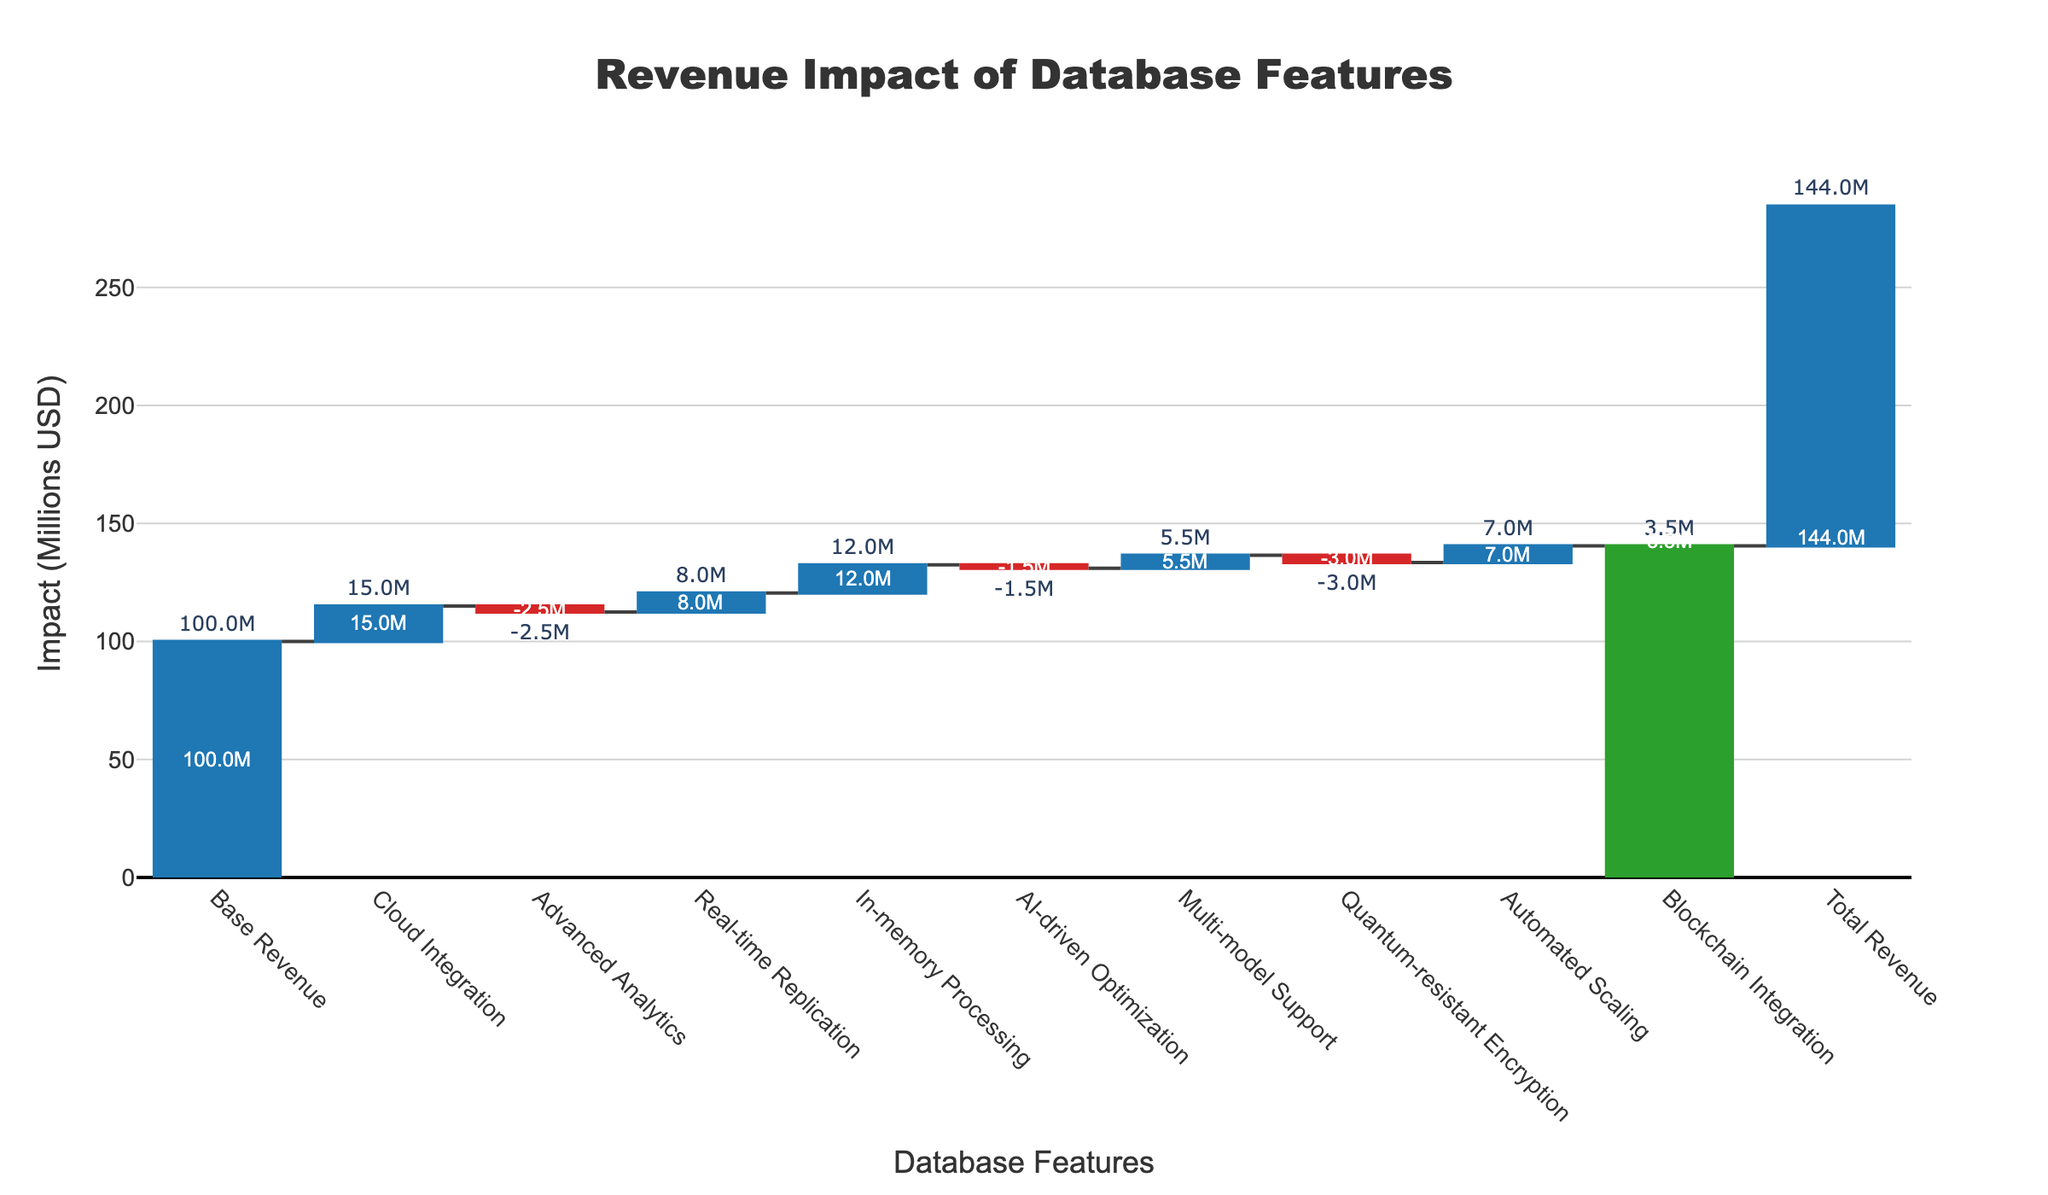What is the title of the figure? Look at the top of the chart where the title is usually located. It reads, "Revenue Impact of Database Features".
Answer: Revenue Impact of Database Features What is the impact of Cloud Integration on revenue? Find the bar labeled "Cloud Integration" and read the corresponding value outside the bar, which shows "+15.0M".
Answer: +15.0M Which feature has the smallest positive impact on revenue? Compare the positive impacts by examining the bars and their values. "Multi-model Support" shows the smallest positive impact with "+5.5M".
Answer: Multi-model Support What are the total additional revenue and total subtracted revenue from the features? Sum the positive impacts: 15.0M (Cloud Integration) + 8.0M (Real-time Replication) + 12.0M (In-memory Processing) + 5.5M (Multi-model Support) + 7.0M (Automated Scaling) + 3.5M (Blockchain Integration) = 51.0M. Sum the negative impacts: -2.5M (Advanced Analytics) + -1.5M (AI-driven Optimization) + -3.0M (Quantum-resistant Encryption) = -7.0M.
Answer: Total positive impact: 51.0M, Total negative impact: -7.0M Excluding the base revenue, what is the combined revenue impact of Advanced Analytics and AI-driven Optimization? Combine the impacts of these two features by adding their values: -2.5M (Advanced Analytics) + -1.5M (AI-driven Optimization) = -4.0M.
Answer: -4.0M How does the impact of Real-time Replication compare to that of Quantum-resistant Encryption? Compare the values of these features: Real-time Replication is +8.0M, while Quantum-resistant Encryption is -3.0M. Real-time Replication has a higher positive impact than the negative impact of Quantum-resistant Encryption.
Answer: Real-time Replication has a higher positive impact What is the total revenue after considering all feature impacts? The final bar labeled "Total Revenue" shows the overall revenue value after all impacts are considered, reading as 144.0M.
Answer: 144.0M How many features have a negative impact on revenue? Count the bars with negative values: Advanced Analytics, AI-driven Optimization, and Quantum-resistant Encryption. There are 3 features.
Answer: 3 What is the overall revenue change due to the listed features? Calculate the sum of all the impacts: 15.0M (Cloud Integration) - 2.5M (Advanced Analytics) + 8.0M (Real-time Replication) + 12.0M (In-memory Processing) - 1.5M (AI-driven Optimization) + 5.5M (Multi-model Support) - 3.0M (Quantum-resistant Encryption) + 7.0M (Automated Scaling) + 3.5M (Blockchain Integration) = 44.0M. This confirms the total revenue change displayed in the figure.
Answer: 44.0M By how much did Automated Scaling increase the revenue? Look at the bar labeled "Automated Scaling" and read the value outside the bar, showing "+7.0M".
Answer: +7.0M 